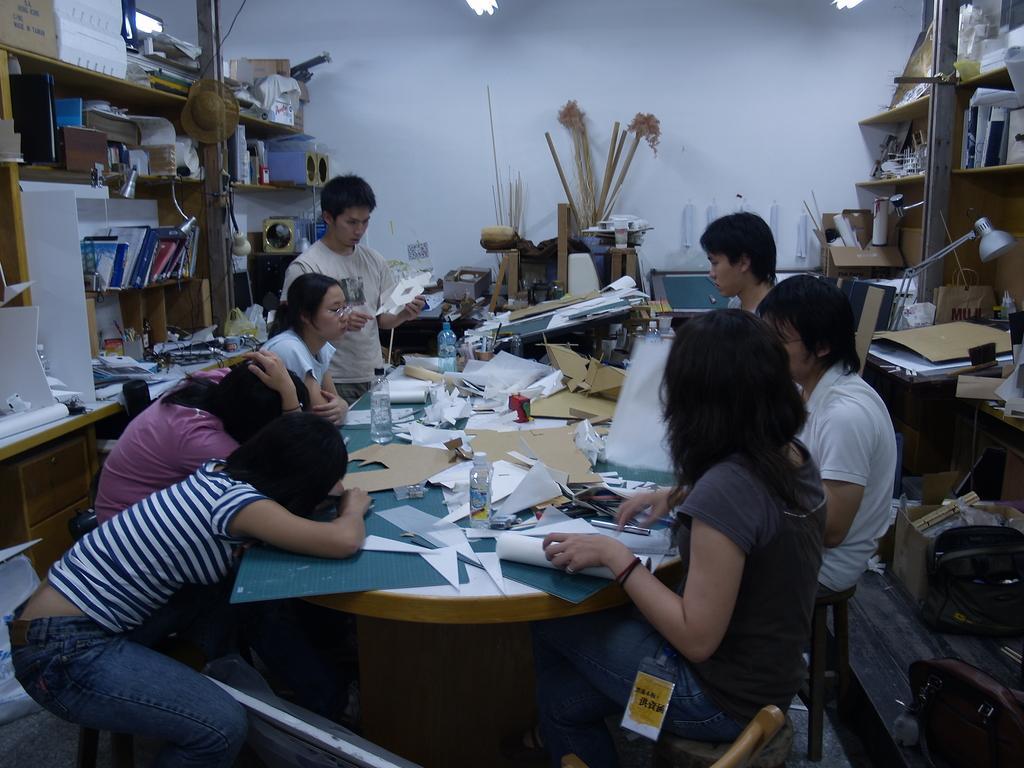Can you describe this image briefly? A indoor picture. Racks are filled with things. This is a lantern lamp. On this table there are papers and bottles. This persons are sitting on chair. This person is standing and holding a paper. Hat is on rack. 